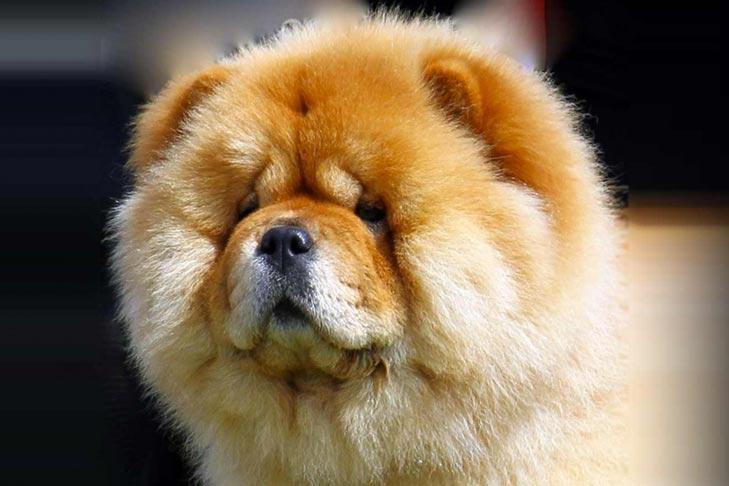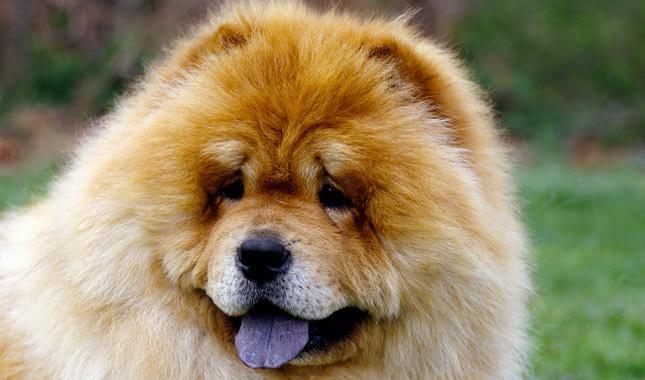The first image is the image on the left, the second image is the image on the right. Given the left and right images, does the statement "A chow dog is standing on all fours on a grayish hard surface, with its body turned leftward." hold true? Answer yes or no. No. The first image is the image on the left, the second image is the image on the right. Given the left and right images, does the statement "The dog in the image on the right is in the grass." hold true? Answer yes or no. Yes. 